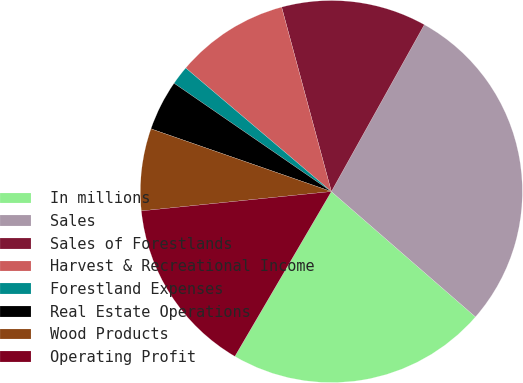Convert chart. <chart><loc_0><loc_0><loc_500><loc_500><pie_chart><fcel>In millions<fcel>Sales<fcel>Sales of Forestlands<fcel>Harvest & Recreational Income<fcel>Forestland Expenses<fcel>Real Estate Operations<fcel>Wood Products<fcel>Operating Profit<nl><fcel>22.03%<fcel>28.3%<fcel>12.28%<fcel>9.61%<fcel>1.6%<fcel>4.27%<fcel>6.94%<fcel>14.95%<nl></chart> 